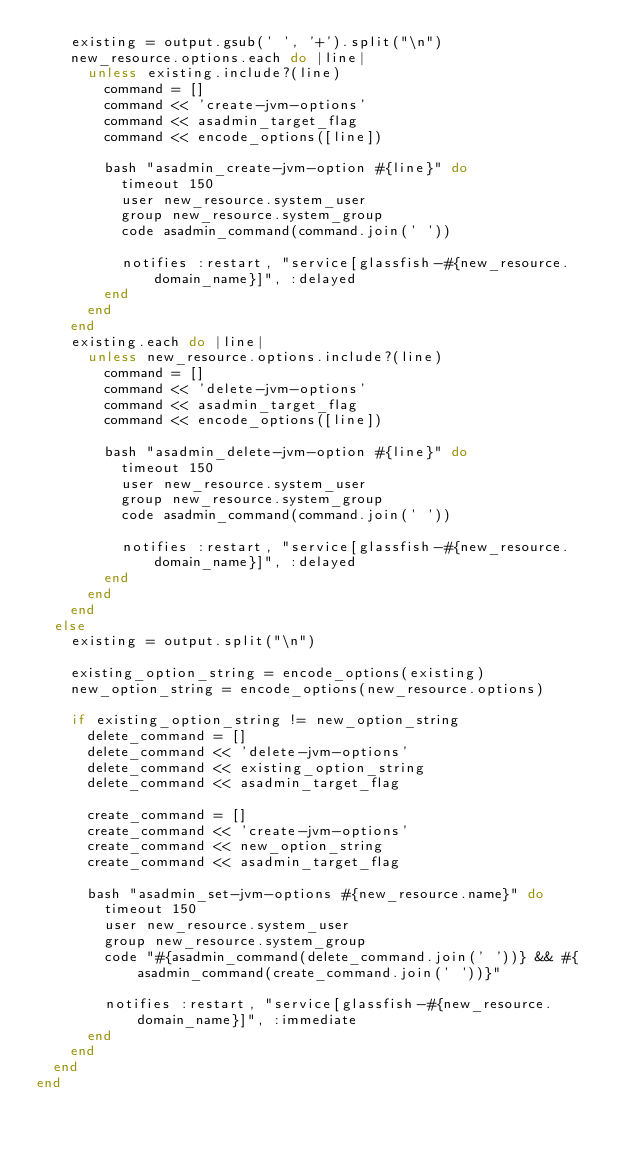Convert code to text. <code><loc_0><loc_0><loc_500><loc_500><_Ruby_>    existing = output.gsub(' ', '+').split("\n")
    new_resource.options.each do |line|
      unless existing.include?(line)
        command = []
        command << 'create-jvm-options'
        command << asadmin_target_flag
        command << encode_options([line])

        bash "asadmin_create-jvm-option #{line}" do
          timeout 150
          user new_resource.system_user
          group new_resource.system_group
          code asadmin_command(command.join(' '))

          notifies :restart, "service[glassfish-#{new_resource.domain_name}]", :delayed
        end
      end
    end
    existing.each do |line|
      unless new_resource.options.include?(line)
        command = []
        command << 'delete-jvm-options'
        command << asadmin_target_flag
        command << encode_options([line])

        bash "asadmin_delete-jvm-option #{line}" do
          timeout 150
          user new_resource.system_user
          group new_resource.system_group
          code asadmin_command(command.join(' '))

          notifies :restart, "service[glassfish-#{new_resource.domain_name}]", :delayed
        end
      end
    end
  else
    existing = output.split("\n")

    existing_option_string = encode_options(existing)
    new_option_string = encode_options(new_resource.options)

    if existing_option_string != new_option_string
      delete_command = []
      delete_command << 'delete-jvm-options'
      delete_command << existing_option_string
      delete_command << asadmin_target_flag

      create_command = []
      create_command << 'create-jvm-options'
      create_command << new_option_string
      create_command << asadmin_target_flag

      bash "asadmin_set-jvm-options #{new_resource.name}" do
        timeout 150
        user new_resource.system_user
        group new_resource.system_group
        code "#{asadmin_command(delete_command.join(' '))} && #{asadmin_command(create_command.join(' '))}"

        notifies :restart, "service[glassfish-#{new_resource.domain_name}]", :immediate
      end
    end
  end
end
</code> 